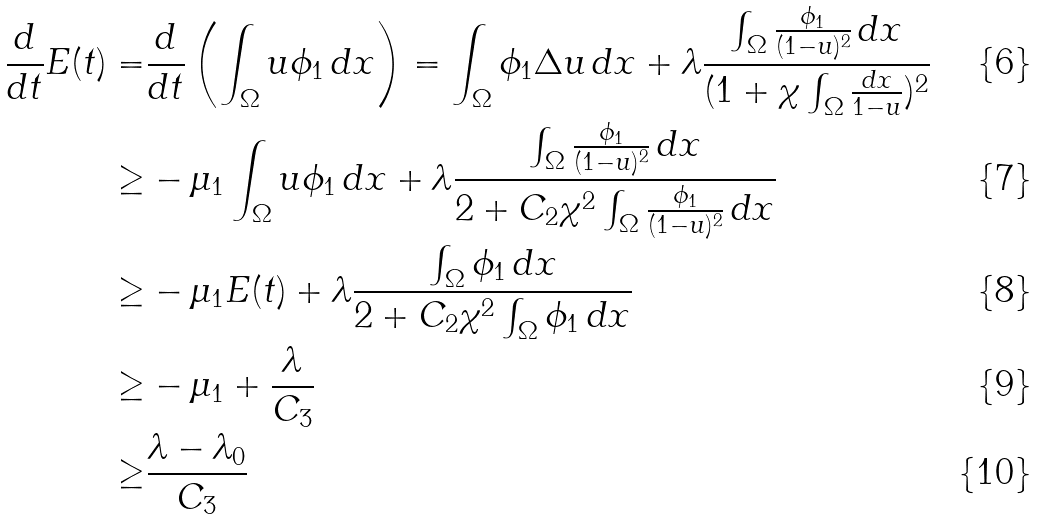Convert formula to latex. <formula><loc_0><loc_0><loc_500><loc_500>\frac { d } { d t } E ( t ) = & \frac { d } { d t } \left ( \int _ { \Omega } u \phi _ { 1 } \, d x \right ) = \int _ { \Omega } \phi _ { 1 } \Delta u \, d x + \lambda \frac { \int _ { \Omega } \frac { \phi _ { 1 } } { ( 1 - u ) ^ { 2 } } \, d x } { ( 1 + \chi \int _ { \Omega } \frac { d x } { 1 - u } ) ^ { 2 } } \\ \geq & - \mu _ { 1 } \int _ { \Omega } u \phi _ { 1 } \, d x + \lambda \frac { \int _ { \Omega } \frac { \phi _ { 1 } } { ( 1 - u ) ^ { 2 } } \, d x } { 2 + C _ { 2 } \chi ^ { 2 } \int _ { \Omega } \frac { \phi _ { 1 } } { ( 1 - u ) ^ { 2 } } \, d x } \\ \geq & - \mu _ { 1 } E ( t ) + \lambda \frac { \int _ { \Omega } \phi _ { 1 } \, d x } { 2 + C _ { 2 } \chi ^ { 2 } \int _ { \Omega } \phi _ { 1 } \, d x } \\ \geq & - \mu _ { 1 } + \frac { \lambda } { C _ { 3 } } \\ \geq & \frac { \lambda - \lambda _ { 0 } } { C _ { 3 } }</formula> 